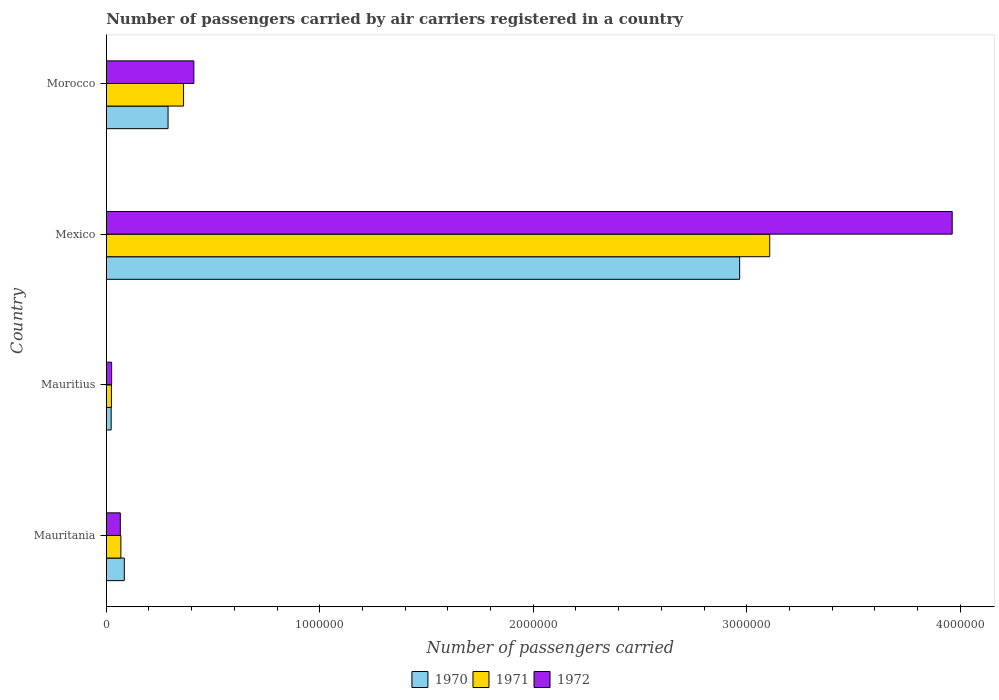How many different coloured bars are there?
Your response must be concise. 3. How many groups of bars are there?
Your answer should be compact. 4. How many bars are there on the 3rd tick from the bottom?
Provide a succinct answer. 3. What is the label of the 2nd group of bars from the top?
Offer a very short reply. Mexico. In how many cases, is the number of bars for a given country not equal to the number of legend labels?
Offer a terse response. 0. What is the number of passengers carried by air carriers in 1970 in Mexico?
Your answer should be compact. 2.97e+06. Across all countries, what is the maximum number of passengers carried by air carriers in 1971?
Keep it short and to the point. 3.11e+06. Across all countries, what is the minimum number of passengers carried by air carriers in 1971?
Provide a short and direct response. 2.42e+04. In which country was the number of passengers carried by air carriers in 1971 maximum?
Give a very brief answer. Mexico. In which country was the number of passengers carried by air carriers in 1970 minimum?
Your response must be concise. Mauritius. What is the total number of passengers carried by air carriers in 1971 in the graph?
Provide a short and direct response. 3.56e+06. What is the difference between the number of passengers carried by air carriers in 1971 in Mauritius and that in Mexico?
Your response must be concise. -3.08e+06. What is the difference between the number of passengers carried by air carriers in 1972 in Morocco and the number of passengers carried by air carriers in 1970 in Mexico?
Give a very brief answer. -2.56e+06. What is the average number of passengers carried by air carriers in 1970 per country?
Ensure brevity in your answer.  8.41e+05. What is the difference between the number of passengers carried by air carriers in 1972 and number of passengers carried by air carriers in 1970 in Mauritius?
Ensure brevity in your answer.  2200. In how many countries, is the number of passengers carried by air carriers in 1971 greater than 3600000 ?
Offer a terse response. 0. What is the ratio of the number of passengers carried by air carriers in 1970 in Mauritius to that in Mexico?
Provide a short and direct response. 0.01. Is the difference between the number of passengers carried by air carriers in 1972 in Mauritania and Morocco greater than the difference between the number of passengers carried by air carriers in 1970 in Mauritania and Morocco?
Your answer should be compact. No. What is the difference between the highest and the second highest number of passengers carried by air carriers in 1970?
Keep it short and to the point. 2.68e+06. What is the difference between the highest and the lowest number of passengers carried by air carriers in 1971?
Make the answer very short. 3.08e+06. Is it the case that in every country, the sum of the number of passengers carried by air carriers in 1970 and number of passengers carried by air carriers in 1972 is greater than the number of passengers carried by air carriers in 1971?
Provide a short and direct response. Yes. Are all the bars in the graph horizontal?
Your answer should be very brief. Yes. How many countries are there in the graph?
Keep it short and to the point. 4. What is the difference between two consecutive major ticks on the X-axis?
Your answer should be compact. 1.00e+06. Are the values on the major ticks of X-axis written in scientific E-notation?
Ensure brevity in your answer.  No. Does the graph contain any zero values?
Provide a succinct answer. No. Does the graph contain grids?
Offer a terse response. No. Where does the legend appear in the graph?
Offer a terse response. Bottom center. How are the legend labels stacked?
Provide a succinct answer. Horizontal. What is the title of the graph?
Your answer should be compact. Number of passengers carried by air carriers registered in a country. Does "2008" appear as one of the legend labels in the graph?
Offer a very short reply. No. What is the label or title of the X-axis?
Your answer should be very brief. Number of passengers carried. What is the Number of passengers carried in 1970 in Mauritania?
Your answer should be compact. 8.45e+04. What is the Number of passengers carried of 1971 in Mauritania?
Provide a succinct answer. 6.84e+04. What is the Number of passengers carried of 1972 in Mauritania?
Your response must be concise. 6.59e+04. What is the Number of passengers carried of 1970 in Mauritius?
Ensure brevity in your answer.  2.30e+04. What is the Number of passengers carried of 1971 in Mauritius?
Offer a very short reply. 2.42e+04. What is the Number of passengers carried in 1972 in Mauritius?
Ensure brevity in your answer.  2.52e+04. What is the Number of passengers carried in 1970 in Mexico?
Your answer should be very brief. 2.97e+06. What is the Number of passengers carried of 1971 in Mexico?
Make the answer very short. 3.11e+06. What is the Number of passengers carried in 1972 in Mexico?
Your answer should be very brief. 3.96e+06. What is the Number of passengers carried of 1970 in Morocco?
Offer a very short reply. 2.90e+05. What is the Number of passengers carried of 1971 in Morocco?
Your response must be concise. 3.62e+05. What is the Number of passengers carried in 1972 in Morocco?
Ensure brevity in your answer.  4.10e+05. Across all countries, what is the maximum Number of passengers carried in 1970?
Offer a terse response. 2.97e+06. Across all countries, what is the maximum Number of passengers carried of 1971?
Give a very brief answer. 3.11e+06. Across all countries, what is the maximum Number of passengers carried of 1972?
Give a very brief answer. 3.96e+06. Across all countries, what is the minimum Number of passengers carried of 1970?
Make the answer very short. 2.30e+04. Across all countries, what is the minimum Number of passengers carried in 1971?
Your response must be concise. 2.42e+04. Across all countries, what is the minimum Number of passengers carried in 1972?
Make the answer very short. 2.52e+04. What is the total Number of passengers carried in 1970 in the graph?
Make the answer very short. 3.36e+06. What is the total Number of passengers carried of 1971 in the graph?
Make the answer very short. 3.56e+06. What is the total Number of passengers carried of 1972 in the graph?
Your response must be concise. 4.46e+06. What is the difference between the Number of passengers carried of 1970 in Mauritania and that in Mauritius?
Keep it short and to the point. 6.15e+04. What is the difference between the Number of passengers carried in 1971 in Mauritania and that in Mauritius?
Ensure brevity in your answer.  4.42e+04. What is the difference between the Number of passengers carried of 1972 in Mauritania and that in Mauritius?
Ensure brevity in your answer.  4.07e+04. What is the difference between the Number of passengers carried in 1970 in Mauritania and that in Mexico?
Offer a terse response. -2.88e+06. What is the difference between the Number of passengers carried of 1971 in Mauritania and that in Mexico?
Offer a very short reply. -3.04e+06. What is the difference between the Number of passengers carried of 1972 in Mauritania and that in Mexico?
Ensure brevity in your answer.  -3.90e+06. What is the difference between the Number of passengers carried in 1970 in Mauritania and that in Morocco?
Keep it short and to the point. -2.05e+05. What is the difference between the Number of passengers carried in 1971 in Mauritania and that in Morocco?
Offer a very short reply. -2.94e+05. What is the difference between the Number of passengers carried in 1972 in Mauritania and that in Morocco?
Offer a terse response. -3.44e+05. What is the difference between the Number of passengers carried in 1970 in Mauritius and that in Mexico?
Ensure brevity in your answer.  -2.94e+06. What is the difference between the Number of passengers carried in 1971 in Mauritius and that in Mexico?
Provide a succinct answer. -3.08e+06. What is the difference between the Number of passengers carried of 1972 in Mauritius and that in Mexico?
Provide a short and direct response. -3.94e+06. What is the difference between the Number of passengers carried of 1970 in Mauritius and that in Morocco?
Offer a terse response. -2.66e+05. What is the difference between the Number of passengers carried of 1971 in Mauritius and that in Morocco?
Offer a very short reply. -3.38e+05. What is the difference between the Number of passengers carried of 1972 in Mauritius and that in Morocco?
Your answer should be very brief. -3.85e+05. What is the difference between the Number of passengers carried in 1970 in Mexico and that in Morocco?
Your response must be concise. 2.68e+06. What is the difference between the Number of passengers carried of 1971 in Mexico and that in Morocco?
Offer a very short reply. 2.75e+06. What is the difference between the Number of passengers carried of 1972 in Mexico and that in Morocco?
Offer a terse response. 3.55e+06. What is the difference between the Number of passengers carried of 1970 in Mauritania and the Number of passengers carried of 1971 in Mauritius?
Make the answer very short. 6.03e+04. What is the difference between the Number of passengers carried of 1970 in Mauritania and the Number of passengers carried of 1972 in Mauritius?
Your response must be concise. 5.93e+04. What is the difference between the Number of passengers carried of 1971 in Mauritania and the Number of passengers carried of 1972 in Mauritius?
Make the answer very short. 4.32e+04. What is the difference between the Number of passengers carried of 1970 in Mauritania and the Number of passengers carried of 1971 in Mexico?
Your answer should be compact. -3.02e+06. What is the difference between the Number of passengers carried of 1970 in Mauritania and the Number of passengers carried of 1972 in Mexico?
Your answer should be compact. -3.88e+06. What is the difference between the Number of passengers carried of 1971 in Mauritania and the Number of passengers carried of 1972 in Mexico?
Offer a terse response. -3.89e+06. What is the difference between the Number of passengers carried of 1970 in Mauritania and the Number of passengers carried of 1971 in Morocco?
Your answer should be very brief. -2.78e+05. What is the difference between the Number of passengers carried in 1970 in Mauritania and the Number of passengers carried in 1972 in Morocco?
Provide a succinct answer. -3.26e+05. What is the difference between the Number of passengers carried in 1971 in Mauritania and the Number of passengers carried in 1972 in Morocco?
Give a very brief answer. -3.42e+05. What is the difference between the Number of passengers carried in 1970 in Mauritius and the Number of passengers carried in 1971 in Mexico?
Give a very brief answer. -3.08e+06. What is the difference between the Number of passengers carried of 1970 in Mauritius and the Number of passengers carried of 1972 in Mexico?
Provide a short and direct response. -3.94e+06. What is the difference between the Number of passengers carried in 1971 in Mauritius and the Number of passengers carried in 1972 in Mexico?
Keep it short and to the point. -3.94e+06. What is the difference between the Number of passengers carried of 1970 in Mauritius and the Number of passengers carried of 1971 in Morocco?
Give a very brief answer. -3.39e+05. What is the difference between the Number of passengers carried of 1970 in Mauritius and the Number of passengers carried of 1972 in Morocco?
Provide a succinct answer. -3.87e+05. What is the difference between the Number of passengers carried in 1971 in Mauritius and the Number of passengers carried in 1972 in Morocco?
Offer a terse response. -3.86e+05. What is the difference between the Number of passengers carried of 1970 in Mexico and the Number of passengers carried of 1971 in Morocco?
Your response must be concise. 2.60e+06. What is the difference between the Number of passengers carried of 1970 in Mexico and the Number of passengers carried of 1972 in Morocco?
Offer a terse response. 2.56e+06. What is the difference between the Number of passengers carried of 1971 in Mexico and the Number of passengers carried of 1972 in Morocco?
Provide a succinct answer. 2.70e+06. What is the average Number of passengers carried of 1970 per country?
Make the answer very short. 8.41e+05. What is the average Number of passengers carried in 1971 per country?
Keep it short and to the point. 8.90e+05. What is the average Number of passengers carried of 1972 per country?
Give a very brief answer. 1.12e+06. What is the difference between the Number of passengers carried in 1970 and Number of passengers carried in 1971 in Mauritania?
Offer a very short reply. 1.61e+04. What is the difference between the Number of passengers carried of 1970 and Number of passengers carried of 1972 in Mauritania?
Ensure brevity in your answer.  1.86e+04. What is the difference between the Number of passengers carried of 1971 and Number of passengers carried of 1972 in Mauritania?
Ensure brevity in your answer.  2500. What is the difference between the Number of passengers carried of 1970 and Number of passengers carried of 1971 in Mauritius?
Your answer should be compact. -1200. What is the difference between the Number of passengers carried in 1970 and Number of passengers carried in 1972 in Mauritius?
Your response must be concise. -2200. What is the difference between the Number of passengers carried of 1971 and Number of passengers carried of 1972 in Mauritius?
Ensure brevity in your answer.  -1000. What is the difference between the Number of passengers carried of 1970 and Number of passengers carried of 1971 in Mexico?
Offer a terse response. -1.41e+05. What is the difference between the Number of passengers carried in 1970 and Number of passengers carried in 1972 in Mexico?
Give a very brief answer. -9.95e+05. What is the difference between the Number of passengers carried of 1971 and Number of passengers carried of 1972 in Mexico?
Offer a very short reply. -8.55e+05. What is the difference between the Number of passengers carried in 1970 and Number of passengers carried in 1971 in Morocco?
Ensure brevity in your answer.  -7.25e+04. What is the difference between the Number of passengers carried of 1970 and Number of passengers carried of 1972 in Morocco?
Offer a terse response. -1.21e+05. What is the difference between the Number of passengers carried of 1971 and Number of passengers carried of 1972 in Morocco?
Keep it short and to the point. -4.83e+04. What is the ratio of the Number of passengers carried in 1970 in Mauritania to that in Mauritius?
Make the answer very short. 3.67. What is the ratio of the Number of passengers carried in 1971 in Mauritania to that in Mauritius?
Your response must be concise. 2.83. What is the ratio of the Number of passengers carried in 1972 in Mauritania to that in Mauritius?
Offer a very short reply. 2.62. What is the ratio of the Number of passengers carried in 1970 in Mauritania to that in Mexico?
Provide a short and direct response. 0.03. What is the ratio of the Number of passengers carried in 1971 in Mauritania to that in Mexico?
Your answer should be very brief. 0.02. What is the ratio of the Number of passengers carried of 1972 in Mauritania to that in Mexico?
Make the answer very short. 0.02. What is the ratio of the Number of passengers carried in 1970 in Mauritania to that in Morocco?
Offer a very short reply. 0.29. What is the ratio of the Number of passengers carried in 1971 in Mauritania to that in Morocco?
Your answer should be compact. 0.19. What is the ratio of the Number of passengers carried of 1972 in Mauritania to that in Morocco?
Offer a terse response. 0.16. What is the ratio of the Number of passengers carried of 1970 in Mauritius to that in Mexico?
Ensure brevity in your answer.  0.01. What is the ratio of the Number of passengers carried of 1971 in Mauritius to that in Mexico?
Give a very brief answer. 0.01. What is the ratio of the Number of passengers carried of 1972 in Mauritius to that in Mexico?
Make the answer very short. 0.01. What is the ratio of the Number of passengers carried of 1970 in Mauritius to that in Morocco?
Ensure brevity in your answer.  0.08. What is the ratio of the Number of passengers carried of 1971 in Mauritius to that in Morocco?
Your response must be concise. 0.07. What is the ratio of the Number of passengers carried in 1972 in Mauritius to that in Morocco?
Keep it short and to the point. 0.06. What is the ratio of the Number of passengers carried of 1970 in Mexico to that in Morocco?
Give a very brief answer. 10.25. What is the ratio of the Number of passengers carried of 1971 in Mexico to that in Morocco?
Ensure brevity in your answer.  8.58. What is the ratio of the Number of passengers carried of 1972 in Mexico to that in Morocco?
Your answer should be very brief. 9.66. What is the difference between the highest and the second highest Number of passengers carried in 1970?
Give a very brief answer. 2.68e+06. What is the difference between the highest and the second highest Number of passengers carried of 1971?
Your answer should be compact. 2.75e+06. What is the difference between the highest and the second highest Number of passengers carried in 1972?
Provide a succinct answer. 3.55e+06. What is the difference between the highest and the lowest Number of passengers carried of 1970?
Provide a succinct answer. 2.94e+06. What is the difference between the highest and the lowest Number of passengers carried in 1971?
Provide a short and direct response. 3.08e+06. What is the difference between the highest and the lowest Number of passengers carried in 1972?
Your answer should be compact. 3.94e+06. 